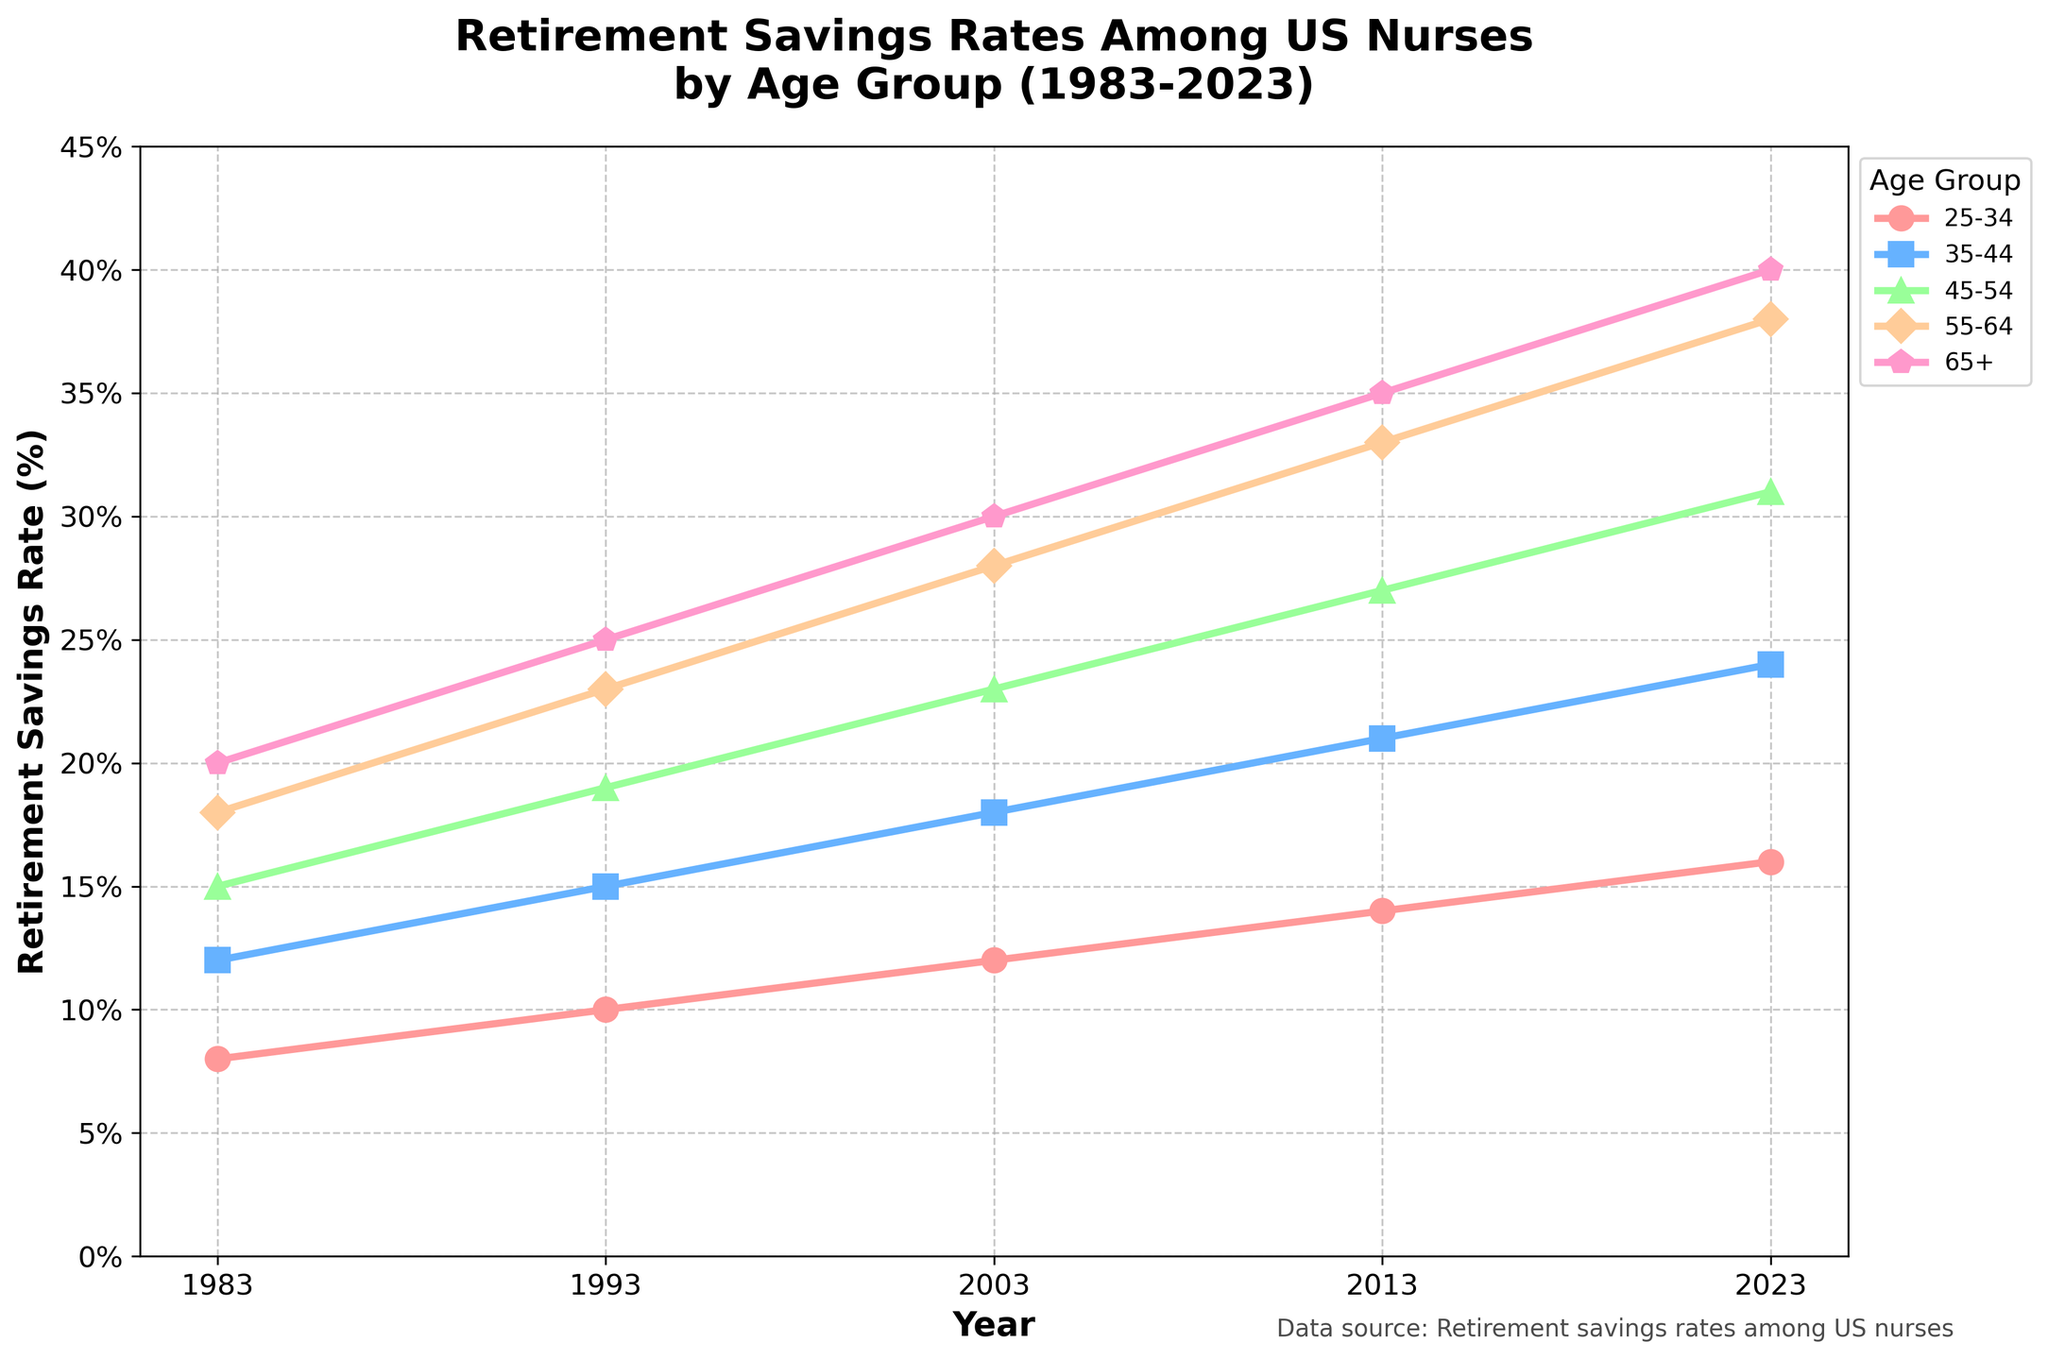What's the trend of retirement savings rates for the age group 45-54 from 1983 to 2023? Observe the data points for the age group 45-54: 15% in 1983, 19% in 1993, 23% in 2003, 27% in 2013, and 31% in 2023. The trend shows a gradual increase in retirement savings rates over the years.
Answer: Increasing Which age group had the highest retirement savings rate in 2023? Look at the end of each line corresponding to the year 2023 and check the values. The age group 65+ has the highest value at 40%.
Answer: 65+ Compare the retirement savings rates between the age groups 35-44 and 55-64 in 1993. Which group saved more, and by how much? For 1993, the retirement savings rate for the age group 35-44 is 15%, and for 55-64, it is 23%. Subtract 15% from 23% to find the difference.
Answer: 55-64 saved 8% more What is the average retirement savings rate across all age groups in the year 2003? Sum the savings rates for each age group in 2003: 12% + 18% + 23% + 28% + 30% = 111%. To find the average, divide by the number of age groups (5).
Answer: 22.2% Between which two consecutive decades did the age group 25-34 see the biggest increase in retirement savings rates? Calculate the differences between each consecutive pair of decades for the age group 25-34: 1993-1983 is 2%, 2003-1993 is 2%, 2013-2003 is 2%, and 2023-2013 is 2%. All increases are equal at 2%, so there is no single biggest increase.
Answer: No difference, all equal What is the color used to represent the age group 35-44? Look for the specific line color corresponding to the age group 35-44. It is represented by a blue line.
Answer: Blue Which age group showed the highest growth rate in retirement savings from 1983 to 2023, and what is the percentage growth? Calculate the growth rate for each age group from 1983 to 2023. For age group 65+, it changed from 20% to 40%, resulting in a 20% increase. This is the highest growth compared to other age groups.
Answer: 65+, 20% 